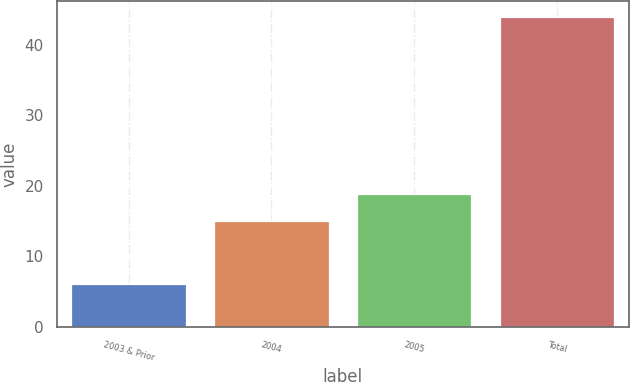<chart> <loc_0><loc_0><loc_500><loc_500><bar_chart><fcel>2003 & Prior<fcel>2004<fcel>2005<fcel>Total<nl><fcel>6<fcel>15<fcel>18.8<fcel>44<nl></chart> 